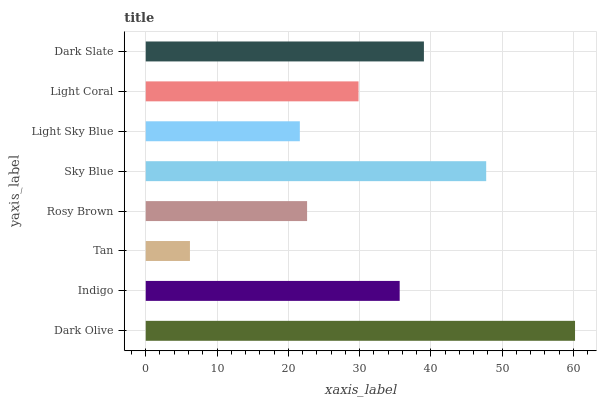Is Tan the minimum?
Answer yes or no. Yes. Is Dark Olive the maximum?
Answer yes or no. Yes. Is Indigo the minimum?
Answer yes or no. No. Is Indigo the maximum?
Answer yes or no. No. Is Dark Olive greater than Indigo?
Answer yes or no. Yes. Is Indigo less than Dark Olive?
Answer yes or no. Yes. Is Indigo greater than Dark Olive?
Answer yes or no. No. Is Dark Olive less than Indigo?
Answer yes or no. No. Is Indigo the high median?
Answer yes or no. Yes. Is Light Coral the low median?
Answer yes or no. Yes. Is Light Sky Blue the high median?
Answer yes or no. No. Is Light Sky Blue the low median?
Answer yes or no. No. 